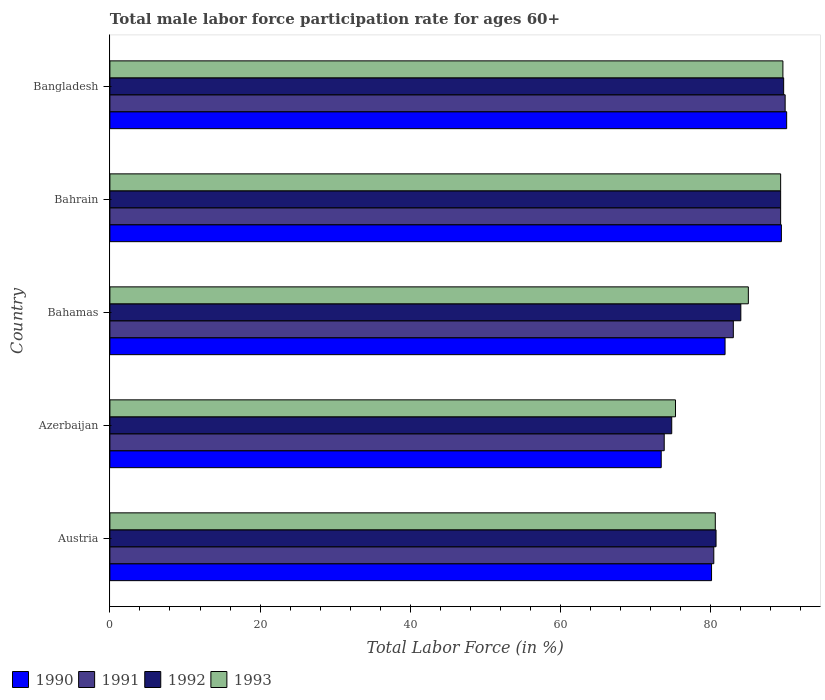How many different coloured bars are there?
Your answer should be compact. 4. Are the number of bars per tick equal to the number of legend labels?
Keep it short and to the point. Yes. What is the label of the 5th group of bars from the top?
Ensure brevity in your answer.  Austria. In how many cases, is the number of bars for a given country not equal to the number of legend labels?
Offer a terse response. 0. What is the male labor force participation rate in 1993 in Bahrain?
Make the answer very short. 89.3. Across all countries, what is the maximum male labor force participation rate in 1992?
Your answer should be very brief. 89.7. Across all countries, what is the minimum male labor force participation rate in 1993?
Provide a short and direct response. 75.3. In which country was the male labor force participation rate in 1991 minimum?
Ensure brevity in your answer.  Azerbaijan. What is the total male labor force participation rate in 1991 in the graph?
Give a very brief answer. 416.4. What is the difference between the male labor force participation rate in 1990 in Austria and that in Bahamas?
Give a very brief answer. -1.8. What is the difference between the male labor force participation rate in 1991 in Bangladesh and the male labor force participation rate in 1992 in Bahamas?
Your answer should be very brief. 5.9. What is the average male labor force participation rate in 1991 per country?
Make the answer very short. 83.28. What is the difference between the male labor force participation rate in 1991 and male labor force participation rate in 1992 in Azerbaijan?
Your response must be concise. -1. In how many countries, is the male labor force participation rate in 1992 greater than 48 %?
Keep it short and to the point. 5. What is the ratio of the male labor force participation rate in 1993 in Austria to that in Bangladesh?
Keep it short and to the point. 0.9. Is the difference between the male labor force participation rate in 1991 in Bahamas and Bangladesh greater than the difference between the male labor force participation rate in 1992 in Bahamas and Bangladesh?
Provide a succinct answer. No. What is the difference between the highest and the second highest male labor force participation rate in 1993?
Your response must be concise. 0.3. What is the difference between the highest and the lowest male labor force participation rate in 1990?
Offer a terse response. 16.7. Is the sum of the male labor force participation rate in 1990 in Azerbaijan and Bahrain greater than the maximum male labor force participation rate in 1993 across all countries?
Keep it short and to the point. Yes. Is it the case that in every country, the sum of the male labor force participation rate in 1991 and male labor force participation rate in 1993 is greater than the sum of male labor force participation rate in 1992 and male labor force participation rate in 1990?
Ensure brevity in your answer.  No. Is it the case that in every country, the sum of the male labor force participation rate in 1991 and male labor force participation rate in 1993 is greater than the male labor force participation rate in 1990?
Make the answer very short. Yes. What is the difference between two consecutive major ticks on the X-axis?
Provide a short and direct response. 20. Does the graph contain any zero values?
Your response must be concise. No. Where does the legend appear in the graph?
Make the answer very short. Bottom left. How many legend labels are there?
Offer a terse response. 4. What is the title of the graph?
Your answer should be compact. Total male labor force participation rate for ages 60+. What is the label or title of the Y-axis?
Your answer should be compact. Country. What is the Total Labor Force (in %) in 1990 in Austria?
Your answer should be very brief. 80.1. What is the Total Labor Force (in %) of 1991 in Austria?
Offer a terse response. 80.4. What is the Total Labor Force (in %) of 1992 in Austria?
Your response must be concise. 80.7. What is the Total Labor Force (in %) of 1993 in Austria?
Provide a short and direct response. 80.6. What is the Total Labor Force (in %) in 1990 in Azerbaijan?
Your answer should be very brief. 73.4. What is the Total Labor Force (in %) in 1991 in Azerbaijan?
Your answer should be very brief. 73.8. What is the Total Labor Force (in %) in 1992 in Azerbaijan?
Your answer should be compact. 74.8. What is the Total Labor Force (in %) of 1993 in Azerbaijan?
Provide a short and direct response. 75.3. What is the Total Labor Force (in %) of 1990 in Bahamas?
Your answer should be compact. 81.9. What is the Total Labor Force (in %) in 1992 in Bahamas?
Give a very brief answer. 84. What is the Total Labor Force (in %) of 1993 in Bahamas?
Ensure brevity in your answer.  85. What is the Total Labor Force (in %) of 1990 in Bahrain?
Offer a very short reply. 89.4. What is the Total Labor Force (in %) in 1991 in Bahrain?
Your answer should be compact. 89.3. What is the Total Labor Force (in %) in 1992 in Bahrain?
Offer a terse response. 89.3. What is the Total Labor Force (in %) in 1993 in Bahrain?
Keep it short and to the point. 89.3. What is the Total Labor Force (in %) in 1990 in Bangladesh?
Ensure brevity in your answer.  90.1. What is the Total Labor Force (in %) in 1991 in Bangladesh?
Provide a succinct answer. 89.9. What is the Total Labor Force (in %) of 1992 in Bangladesh?
Provide a succinct answer. 89.7. What is the Total Labor Force (in %) in 1993 in Bangladesh?
Provide a short and direct response. 89.6. Across all countries, what is the maximum Total Labor Force (in %) of 1990?
Your answer should be compact. 90.1. Across all countries, what is the maximum Total Labor Force (in %) in 1991?
Ensure brevity in your answer.  89.9. Across all countries, what is the maximum Total Labor Force (in %) of 1992?
Ensure brevity in your answer.  89.7. Across all countries, what is the maximum Total Labor Force (in %) in 1993?
Provide a short and direct response. 89.6. Across all countries, what is the minimum Total Labor Force (in %) in 1990?
Give a very brief answer. 73.4. Across all countries, what is the minimum Total Labor Force (in %) of 1991?
Ensure brevity in your answer.  73.8. Across all countries, what is the minimum Total Labor Force (in %) of 1992?
Offer a terse response. 74.8. Across all countries, what is the minimum Total Labor Force (in %) in 1993?
Offer a very short reply. 75.3. What is the total Total Labor Force (in %) in 1990 in the graph?
Offer a terse response. 414.9. What is the total Total Labor Force (in %) of 1991 in the graph?
Keep it short and to the point. 416.4. What is the total Total Labor Force (in %) in 1992 in the graph?
Provide a short and direct response. 418.5. What is the total Total Labor Force (in %) of 1993 in the graph?
Ensure brevity in your answer.  419.8. What is the difference between the Total Labor Force (in %) in 1990 in Austria and that in Azerbaijan?
Provide a succinct answer. 6.7. What is the difference between the Total Labor Force (in %) in 1993 in Austria and that in Azerbaijan?
Give a very brief answer. 5.3. What is the difference between the Total Labor Force (in %) of 1990 in Austria and that in Bahamas?
Provide a succinct answer. -1.8. What is the difference between the Total Labor Force (in %) in 1991 in Austria and that in Bahamas?
Keep it short and to the point. -2.6. What is the difference between the Total Labor Force (in %) of 1992 in Austria and that in Bahamas?
Your answer should be very brief. -3.3. What is the difference between the Total Labor Force (in %) in 1993 in Austria and that in Bahamas?
Give a very brief answer. -4.4. What is the difference between the Total Labor Force (in %) in 1990 in Austria and that in Bahrain?
Ensure brevity in your answer.  -9.3. What is the difference between the Total Labor Force (in %) in 1993 in Austria and that in Bahrain?
Your response must be concise. -8.7. What is the difference between the Total Labor Force (in %) in 1991 in Austria and that in Bangladesh?
Offer a terse response. -9.5. What is the difference between the Total Labor Force (in %) of 1992 in Austria and that in Bangladesh?
Ensure brevity in your answer.  -9. What is the difference between the Total Labor Force (in %) of 1993 in Austria and that in Bangladesh?
Provide a short and direct response. -9. What is the difference between the Total Labor Force (in %) in 1991 in Azerbaijan and that in Bahrain?
Your response must be concise. -15.5. What is the difference between the Total Labor Force (in %) in 1992 in Azerbaijan and that in Bahrain?
Provide a succinct answer. -14.5. What is the difference between the Total Labor Force (in %) of 1990 in Azerbaijan and that in Bangladesh?
Your answer should be compact. -16.7. What is the difference between the Total Labor Force (in %) of 1991 in Azerbaijan and that in Bangladesh?
Keep it short and to the point. -16.1. What is the difference between the Total Labor Force (in %) in 1992 in Azerbaijan and that in Bangladesh?
Your answer should be very brief. -14.9. What is the difference between the Total Labor Force (in %) in 1993 in Azerbaijan and that in Bangladesh?
Provide a short and direct response. -14.3. What is the difference between the Total Labor Force (in %) of 1992 in Bahamas and that in Bahrain?
Offer a terse response. -5.3. What is the difference between the Total Labor Force (in %) in 1993 in Bahamas and that in Bahrain?
Give a very brief answer. -4.3. What is the difference between the Total Labor Force (in %) of 1990 in Bahamas and that in Bangladesh?
Offer a very short reply. -8.2. What is the difference between the Total Labor Force (in %) in 1991 in Bahamas and that in Bangladesh?
Keep it short and to the point. -6.9. What is the difference between the Total Labor Force (in %) of 1992 in Bahamas and that in Bangladesh?
Provide a short and direct response. -5.7. What is the difference between the Total Labor Force (in %) of 1991 in Bahrain and that in Bangladesh?
Your response must be concise. -0.6. What is the difference between the Total Labor Force (in %) in 1993 in Bahrain and that in Bangladesh?
Ensure brevity in your answer.  -0.3. What is the difference between the Total Labor Force (in %) of 1990 in Austria and the Total Labor Force (in %) of 1993 in Azerbaijan?
Keep it short and to the point. 4.8. What is the difference between the Total Labor Force (in %) of 1991 in Austria and the Total Labor Force (in %) of 1993 in Azerbaijan?
Provide a succinct answer. 5.1. What is the difference between the Total Labor Force (in %) of 1992 in Austria and the Total Labor Force (in %) of 1993 in Azerbaijan?
Make the answer very short. 5.4. What is the difference between the Total Labor Force (in %) of 1990 in Austria and the Total Labor Force (in %) of 1992 in Bahamas?
Provide a short and direct response. -3.9. What is the difference between the Total Labor Force (in %) of 1991 in Austria and the Total Labor Force (in %) of 1992 in Bahamas?
Offer a very short reply. -3.6. What is the difference between the Total Labor Force (in %) of 1990 in Austria and the Total Labor Force (in %) of 1991 in Bahrain?
Give a very brief answer. -9.2. What is the difference between the Total Labor Force (in %) in 1992 in Austria and the Total Labor Force (in %) in 1993 in Bahrain?
Your response must be concise. -8.6. What is the difference between the Total Labor Force (in %) in 1992 in Austria and the Total Labor Force (in %) in 1993 in Bangladesh?
Offer a terse response. -8.9. What is the difference between the Total Labor Force (in %) of 1990 in Azerbaijan and the Total Labor Force (in %) of 1991 in Bahamas?
Your answer should be compact. -9.6. What is the difference between the Total Labor Force (in %) of 1990 in Azerbaijan and the Total Labor Force (in %) of 1992 in Bahamas?
Provide a short and direct response. -10.6. What is the difference between the Total Labor Force (in %) of 1990 in Azerbaijan and the Total Labor Force (in %) of 1993 in Bahamas?
Make the answer very short. -11.6. What is the difference between the Total Labor Force (in %) in 1991 in Azerbaijan and the Total Labor Force (in %) in 1992 in Bahamas?
Ensure brevity in your answer.  -10.2. What is the difference between the Total Labor Force (in %) in 1991 in Azerbaijan and the Total Labor Force (in %) in 1993 in Bahamas?
Your response must be concise. -11.2. What is the difference between the Total Labor Force (in %) of 1992 in Azerbaijan and the Total Labor Force (in %) of 1993 in Bahamas?
Make the answer very short. -10.2. What is the difference between the Total Labor Force (in %) of 1990 in Azerbaijan and the Total Labor Force (in %) of 1991 in Bahrain?
Keep it short and to the point. -15.9. What is the difference between the Total Labor Force (in %) of 1990 in Azerbaijan and the Total Labor Force (in %) of 1992 in Bahrain?
Your answer should be very brief. -15.9. What is the difference between the Total Labor Force (in %) of 1990 in Azerbaijan and the Total Labor Force (in %) of 1993 in Bahrain?
Give a very brief answer. -15.9. What is the difference between the Total Labor Force (in %) in 1991 in Azerbaijan and the Total Labor Force (in %) in 1992 in Bahrain?
Provide a succinct answer. -15.5. What is the difference between the Total Labor Force (in %) in 1991 in Azerbaijan and the Total Labor Force (in %) in 1993 in Bahrain?
Your response must be concise. -15.5. What is the difference between the Total Labor Force (in %) of 1992 in Azerbaijan and the Total Labor Force (in %) of 1993 in Bahrain?
Ensure brevity in your answer.  -14.5. What is the difference between the Total Labor Force (in %) in 1990 in Azerbaijan and the Total Labor Force (in %) in 1991 in Bangladesh?
Provide a short and direct response. -16.5. What is the difference between the Total Labor Force (in %) of 1990 in Azerbaijan and the Total Labor Force (in %) of 1992 in Bangladesh?
Ensure brevity in your answer.  -16.3. What is the difference between the Total Labor Force (in %) in 1990 in Azerbaijan and the Total Labor Force (in %) in 1993 in Bangladesh?
Provide a short and direct response. -16.2. What is the difference between the Total Labor Force (in %) in 1991 in Azerbaijan and the Total Labor Force (in %) in 1992 in Bangladesh?
Offer a very short reply. -15.9. What is the difference between the Total Labor Force (in %) of 1991 in Azerbaijan and the Total Labor Force (in %) of 1993 in Bangladesh?
Offer a terse response. -15.8. What is the difference between the Total Labor Force (in %) in 1992 in Azerbaijan and the Total Labor Force (in %) in 1993 in Bangladesh?
Ensure brevity in your answer.  -14.8. What is the difference between the Total Labor Force (in %) of 1990 in Bahamas and the Total Labor Force (in %) of 1992 in Bahrain?
Your answer should be compact. -7.4. What is the difference between the Total Labor Force (in %) of 1990 in Bahamas and the Total Labor Force (in %) of 1993 in Bahrain?
Offer a terse response. -7.4. What is the difference between the Total Labor Force (in %) of 1991 in Bahamas and the Total Labor Force (in %) of 1993 in Bahrain?
Offer a terse response. -6.3. What is the difference between the Total Labor Force (in %) of 1990 in Bahamas and the Total Labor Force (in %) of 1991 in Bangladesh?
Give a very brief answer. -8. What is the difference between the Total Labor Force (in %) in 1990 in Bahamas and the Total Labor Force (in %) in 1992 in Bangladesh?
Keep it short and to the point. -7.8. What is the difference between the Total Labor Force (in %) of 1990 in Bahamas and the Total Labor Force (in %) of 1993 in Bangladesh?
Give a very brief answer. -7.7. What is the difference between the Total Labor Force (in %) of 1991 in Bahamas and the Total Labor Force (in %) of 1992 in Bangladesh?
Provide a short and direct response. -6.7. What is the difference between the Total Labor Force (in %) in 1992 in Bahamas and the Total Labor Force (in %) in 1993 in Bangladesh?
Your answer should be compact. -5.6. What is the difference between the Total Labor Force (in %) in 1990 in Bahrain and the Total Labor Force (in %) in 1992 in Bangladesh?
Provide a short and direct response. -0.3. What is the average Total Labor Force (in %) in 1990 per country?
Keep it short and to the point. 82.98. What is the average Total Labor Force (in %) of 1991 per country?
Your response must be concise. 83.28. What is the average Total Labor Force (in %) of 1992 per country?
Your answer should be compact. 83.7. What is the average Total Labor Force (in %) of 1993 per country?
Offer a terse response. 83.96. What is the difference between the Total Labor Force (in %) of 1990 and Total Labor Force (in %) of 1991 in Austria?
Your answer should be compact. -0.3. What is the difference between the Total Labor Force (in %) in 1990 and Total Labor Force (in %) in 1992 in Austria?
Provide a succinct answer. -0.6. What is the difference between the Total Labor Force (in %) of 1990 and Total Labor Force (in %) of 1992 in Azerbaijan?
Your answer should be compact. -1.4. What is the difference between the Total Labor Force (in %) in 1990 and Total Labor Force (in %) in 1991 in Bahamas?
Offer a very short reply. -1.1. What is the difference between the Total Labor Force (in %) in 1990 and Total Labor Force (in %) in 1992 in Bahamas?
Your answer should be compact. -2.1. What is the difference between the Total Labor Force (in %) of 1990 and Total Labor Force (in %) of 1993 in Bahamas?
Your answer should be very brief. -3.1. What is the difference between the Total Labor Force (in %) of 1991 and Total Labor Force (in %) of 1993 in Bahamas?
Make the answer very short. -2. What is the difference between the Total Labor Force (in %) of 1990 and Total Labor Force (in %) of 1992 in Bahrain?
Ensure brevity in your answer.  0.1. What is the difference between the Total Labor Force (in %) of 1991 and Total Labor Force (in %) of 1992 in Bahrain?
Make the answer very short. 0. What is the difference between the Total Labor Force (in %) of 1992 and Total Labor Force (in %) of 1993 in Bahrain?
Offer a terse response. 0. What is the difference between the Total Labor Force (in %) in 1990 and Total Labor Force (in %) in 1991 in Bangladesh?
Your response must be concise. 0.2. What is the difference between the Total Labor Force (in %) of 1990 and Total Labor Force (in %) of 1992 in Bangladesh?
Offer a very short reply. 0.4. What is the difference between the Total Labor Force (in %) in 1990 and Total Labor Force (in %) in 1993 in Bangladesh?
Make the answer very short. 0.5. What is the difference between the Total Labor Force (in %) of 1991 and Total Labor Force (in %) of 1993 in Bangladesh?
Your response must be concise. 0.3. What is the difference between the Total Labor Force (in %) of 1992 and Total Labor Force (in %) of 1993 in Bangladesh?
Provide a succinct answer. 0.1. What is the ratio of the Total Labor Force (in %) of 1990 in Austria to that in Azerbaijan?
Provide a short and direct response. 1.09. What is the ratio of the Total Labor Force (in %) of 1991 in Austria to that in Azerbaijan?
Provide a short and direct response. 1.09. What is the ratio of the Total Labor Force (in %) of 1992 in Austria to that in Azerbaijan?
Your answer should be compact. 1.08. What is the ratio of the Total Labor Force (in %) of 1993 in Austria to that in Azerbaijan?
Your response must be concise. 1.07. What is the ratio of the Total Labor Force (in %) of 1991 in Austria to that in Bahamas?
Keep it short and to the point. 0.97. What is the ratio of the Total Labor Force (in %) of 1992 in Austria to that in Bahamas?
Your answer should be compact. 0.96. What is the ratio of the Total Labor Force (in %) in 1993 in Austria to that in Bahamas?
Provide a short and direct response. 0.95. What is the ratio of the Total Labor Force (in %) in 1990 in Austria to that in Bahrain?
Offer a very short reply. 0.9. What is the ratio of the Total Labor Force (in %) of 1991 in Austria to that in Bahrain?
Give a very brief answer. 0.9. What is the ratio of the Total Labor Force (in %) in 1992 in Austria to that in Bahrain?
Offer a terse response. 0.9. What is the ratio of the Total Labor Force (in %) in 1993 in Austria to that in Bahrain?
Your answer should be compact. 0.9. What is the ratio of the Total Labor Force (in %) in 1990 in Austria to that in Bangladesh?
Ensure brevity in your answer.  0.89. What is the ratio of the Total Labor Force (in %) in 1991 in Austria to that in Bangladesh?
Offer a terse response. 0.89. What is the ratio of the Total Labor Force (in %) in 1992 in Austria to that in Bangladesh?
Offer a terse response. 0.9. What is the ratio of the Total Labor Force (in %) of 1993 in Austria to that in Bangladesh?
Your response must be concise. 0.9. What is the ratio of the Total Labor Force (in %) in 1990 in Azerbaijan to that in Bahamas?
Offer a terse response. 0.9. What is the ratio of the Total Labor Force (in %) in 1991 in Azerbaijan to that in Bahamas?
Your answer should be very brief. 0.89. What is the ratio of the Total Labor Force (in %) in 1992 in Azerbaijan to that in Bahamas?
Provide a succinct answer. 0.89. What is the ratio of the Total Labor Force (in %) of 1993 in Azerbaijan to that in Bahamas?
Offer a terse response. 0.89. What is the ratio of the Total Labor Force (in %) in 1990 in Azerbaijan to that in Bahrain?
Provide a short and direct response. 0.82. What is the ratio of the Total Labor Force (in %) of 1991 in Azerbaijan to that in Bahrain?
Offer a terse response. 0.83. What is the ratio of the Total Labor Force (in %) of 1992 in Azerbaijan to that in Bahrain?
Keep it short and to the point. 0.84. What is the ratio of the Total Labor Force (in %) of 1993 in Azerbaijan to that in Bahrain?
Offer a terse response. 0.84. What is the ratio of the Total Labor Force (in %) in 1990 in Azerbaijan to that in Bangladesh?
Ensure brevity in your answer.  0.81. What is the ratio of the Total Labor Force (in %) in 1991 in Azerbaijan to that in Bangladesh?
Keep it short and to the point. 0.82. What is the ratio of the Total Labor Force (in %) of 1992 in Azerbaijan to that in Bangladesh?
Give a very brief answer. 0.83. What is the ratio of the Total Labor Force (in %) in 1993 in Azerbaijan to that in Bangladesh?
Provide a succinct answer. 0.84. What is the ratio of the Total Labor Force (in %) in 1990 in Bahamas to that in Bahrain?
Ensure brevity in your answer.  0.92. What is the ratio of the Total Labor Force (in %) in 1991 in Bahamas to that in Bahrain?
Offer a very short reply. 0.93. What is the ratio of the Total Labor Force (in %) of 1992 in Bahamas to that in Bahrain?
Make the answer very short. 0.94. What is the ratio of the Total Labor Force (in %) in 1993 in Bahamas to that in Bahrain?
Provide a short and direct response. 0.95. What is the ratio of the Total Labor Force (in %) of 1990 in Bahamas to that in Bangladesh?
Provide a short and direct response. 0.91. What is the ratio of the Total Labor Force (in %) in 1991 in Bahamas to that in Bangladesh?
Make the answer very short. 0.92. What is the ratio of the Total Labor Force (in %) in 1992 in Bahamas to that in Bangladesh?
Offer a terse response. 0.94. What is the ratio of the Total Labor Force (in %) of 1993 in Bahamas to that in Bangladesh?
Keep it short and to the point. 0.95. What is the ratio of the Total Labor Force (in %) in 1992 in Bahrain to that in Bangladesh?
Your answer should be very brief. 1. What is the ratio of the Total Labor Force (in %) in 1993 in Bahrain to that in Bangladesh?
Provide a succinct answer. 1. What is the difference between the highest and the second highest Total Labor Force (in %) in 1991?
Offer a terse response. 0.6. What is the difference between the highest and the second highest Total Labor Force (in %) in 1993?
Ensure brevity in your answer.  0.3. What is the difference between the highest and the lowest Total Labor Force (in %) in 1992?
Provide a succinct answer. 14.9. What is the difference between the highest and the lowest Total Labor Force (in %) in 1993?
Keep it short and to the point. 14.3. 